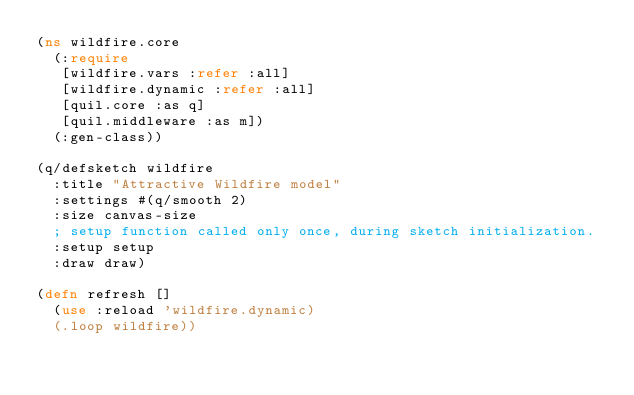Convert code to text. <code><loc_0><loc_0><loc_500><loc_500><_Clojure_>(ns wildfire.core
  (:require 
   [wildfire.vars :refer :all]
   [wildfire.dynamic :refer :all]
   [quil.core :as q]
   [quil.middleware :as m])
  (:gen-class))

(q/defsketch wildfire
  :title "Attractive Wildfire model"
  :settings #(q/smooth 2)
  :size canvas-size
  ; setup function called only once, during sketch initialization.
  :setup setup
  :draw draw)

(defn refresh []
  (use :reload 'wildfire.dynamic)
  (.loop wildfire))
</code> 